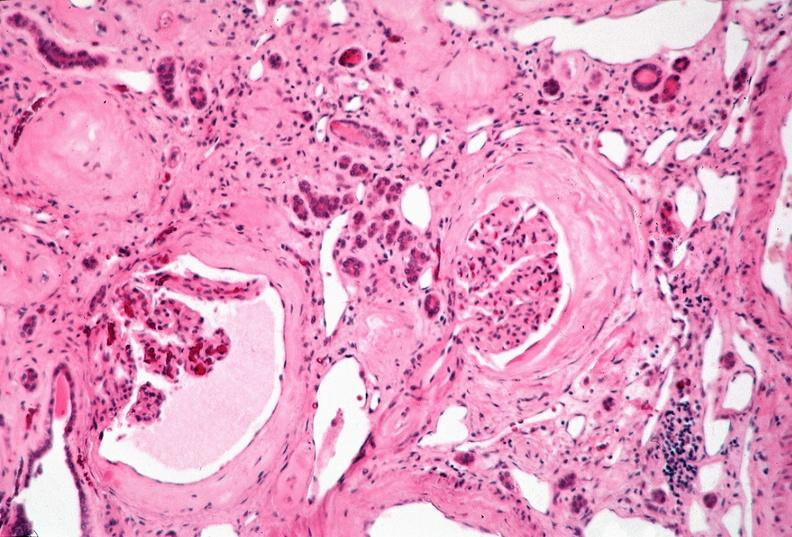does this image show kidney, adult polycystic kidney?
Answer the question using a single word or phrase. Yes 